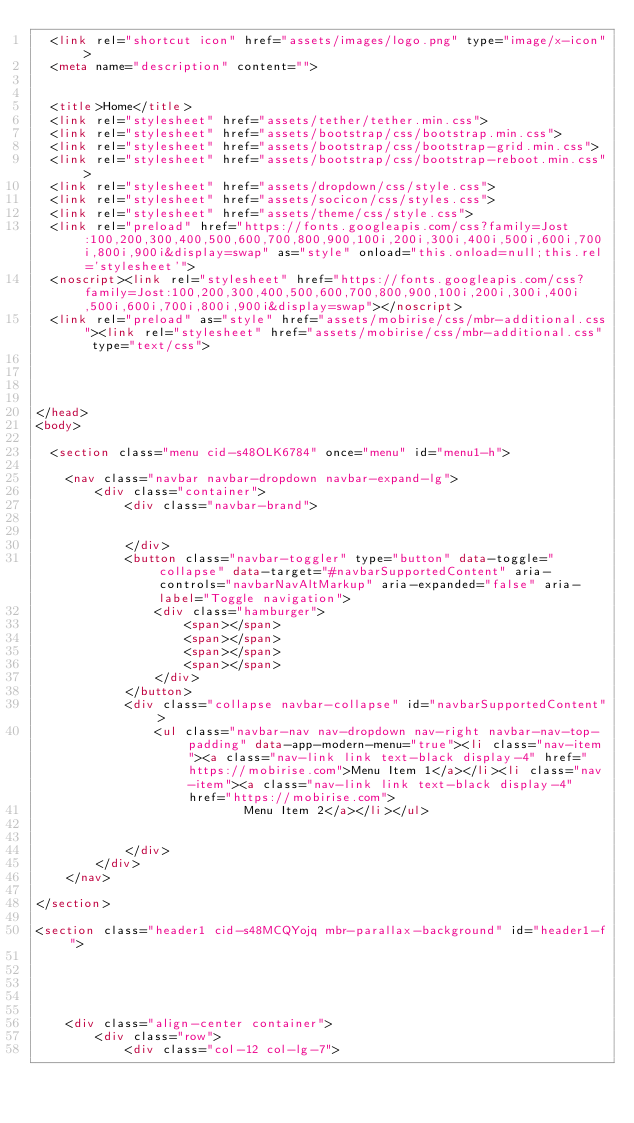<code> <loc_0><loc_0><loc_500><loc_500><_HTML_>  <link rel="shortcut icon" href="assets/images/logo.png" type="image/x-icon">
  <meta name="description" content="">
  
  
  <title>Home</title>
  <link rel="stylesheet" href="assets/tether/tether.min.css">
  <link rel="stylesheet" href="assets/bootstrap/css/bootstrap.min.css">
  <link rel="stylesheet" href="assets/bootstrap/css/bootstrap-grid.min.css">
  <link rel="stylesheet" href="assets/bootstrap/css/bootstrap-reboot.min.css">
  <link rel="stylesheet" href="assets/dropdown/css/style.css">
  <link rel="stylesheet" href="assets/socicon/css/styles.css">
  <link rel="stylesheet" href="assets/theme/css/style.css">
  <link rel="preload" href="https://fonts.googleapis.com/css?family=Jost:100,200,300,400,500,600,700,800,900,100i,200i,300i,400i,500i,600i,700i,800i,900i&display=swap" as="style" onload="this.onload=null;this.rel='stylesheet'">
  <noscript><link rel="stylesheet" href="https://fonts.googleapis.com/css?family=Jost:100,200,300,400,500,600,700,800,900,100i,200i,300i,400i,500i,600i,700i,800i,900i&display=swap"></noscript>
  <link rel="preload" as="style" href="assets/mobirise/css/mbr-additional.css"><link rel="stylesheet" href="assets/mobirise/css/mbr-additional.css" type="text/css">
  
  
  
  
</head>
<body>
  
  <section class="menu cid-s48OLK6784" once="menu" id="menu1-h">
    
    <nav class="navbar navbar-dropdown navbar-expand-lg">
        <div class="container">
            <div class="navbar-brand">
                
                
            </div>
            <button class="navbar-toggler" type="button" data-toggle="collapse" data-target="#navbarSupportedContent" aria-controls="navbarNavAltMarkup" aria-expanded="false" aria-label="Toggle navigation">
                <div class="hamburger">
                    <span></span>
                    <span></span>
                    <span></span>
                    <span></span>
                </div>
            </button>
            <div class="collapse navbar-collapse" id="navbarSupportedContent">
                <ul class="navbar-nav nav-dropdown nav-right navbar-nav-top-padding" data-app-modern-menu="true"><li class="nav-item"><a class="nav-link link text-black display-4" href="https://mobirise.com">Menu Item 1</a></li><li class="nav-item"><a class="nav-link link text-black display-4" href="https://mobirise.com">
                            Menu Item 2</a></li></ul>
                
                
            </div>
        </div>
    </nav>

</section>

<section class="header1 cid-s48MCQYojq mbr-parallax-background" id="header1-f">

    

    

    <div class="align-center container">
        <div class="row">
            <div class="col-12 col-lg-7">
                
                </code> 